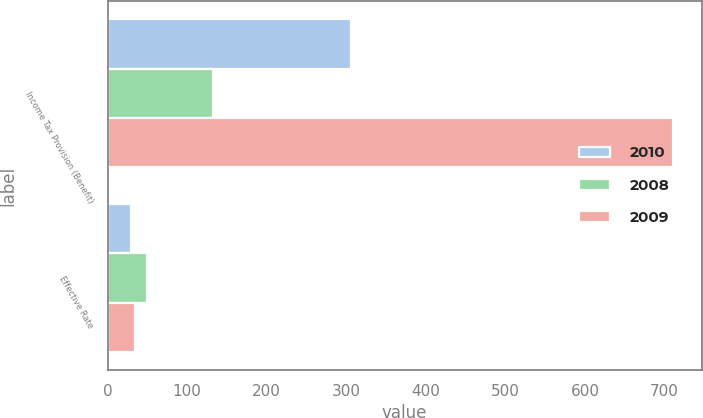<chart> <loc_0><loc_0><loc_500><loc_500><stacked_bar_chart><ecel><fcel>Income Tax Provision (Benefit)<fcel>Effective Rate<nl><fcel>2010<fcel>306<fcel>30<nl><fcel>2008<fcel>133<fcel>50<nl><fcel>2009<fcel>711<fcel>35<nl></chart> 